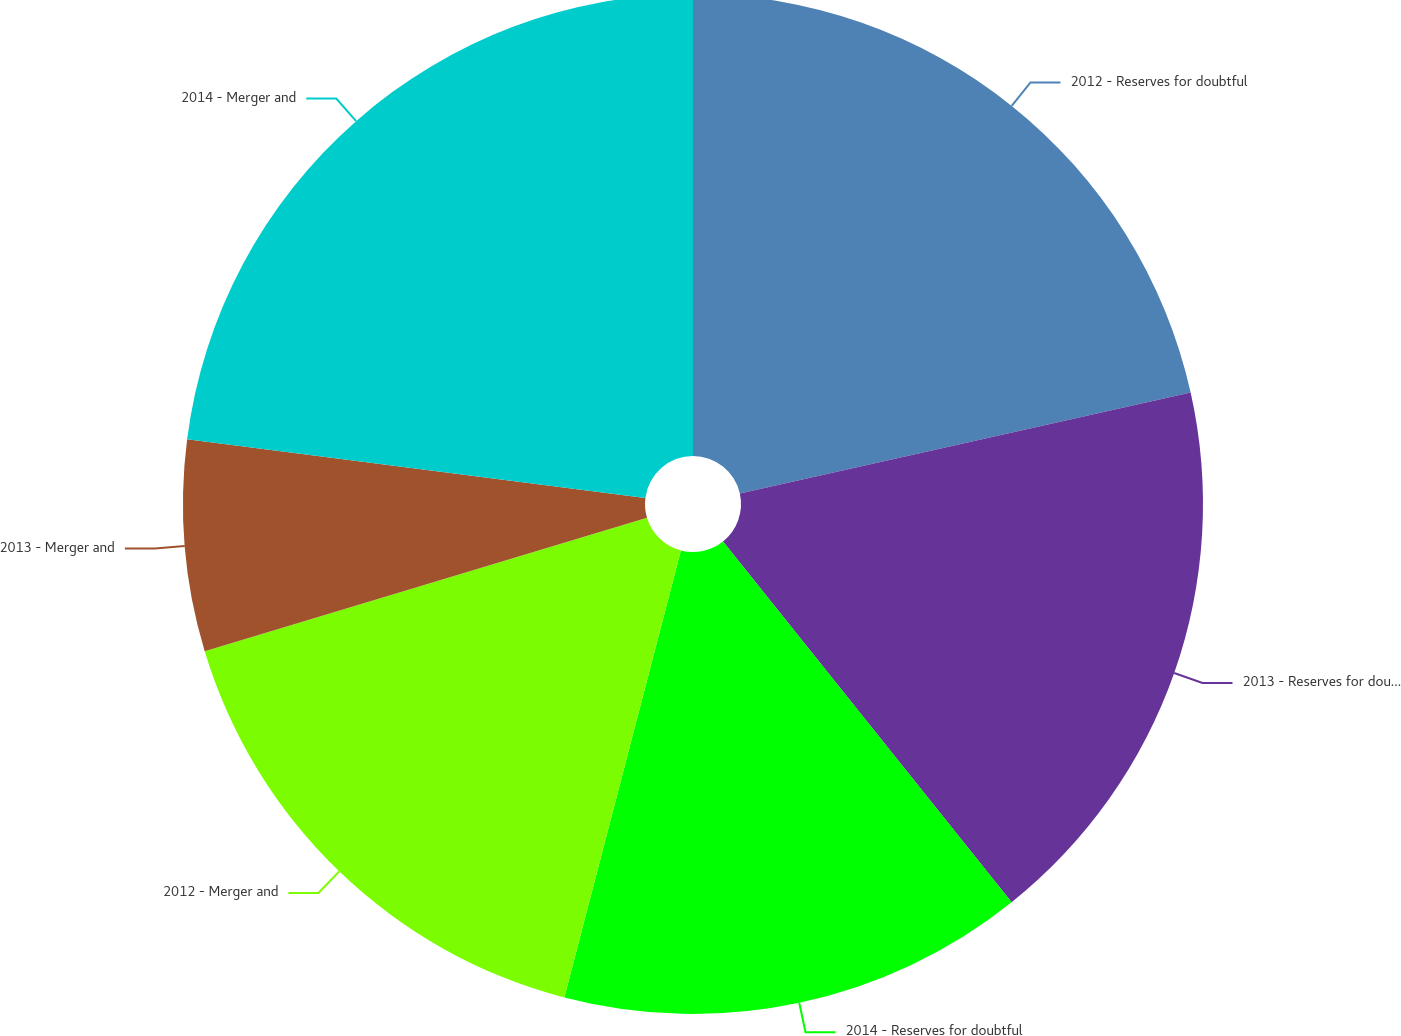<chart> <loc_0><loc_0><loc_500><loc_500><pie_chart><fcel>2012 - Reserves for doubtful<fcel>2013 - Reserves for doubtful<fcel>2014 - Reserves for doubtful<fcel>2012 - Merger and<fcel>2013 - Merger and<fcel>2014 - Merger and<nl><fcel>21.49%<fcel>17.77%<fcel>14.8%<fcel>16.28%<fcel>6.69%<fcel>22.97%<nl></chart> 